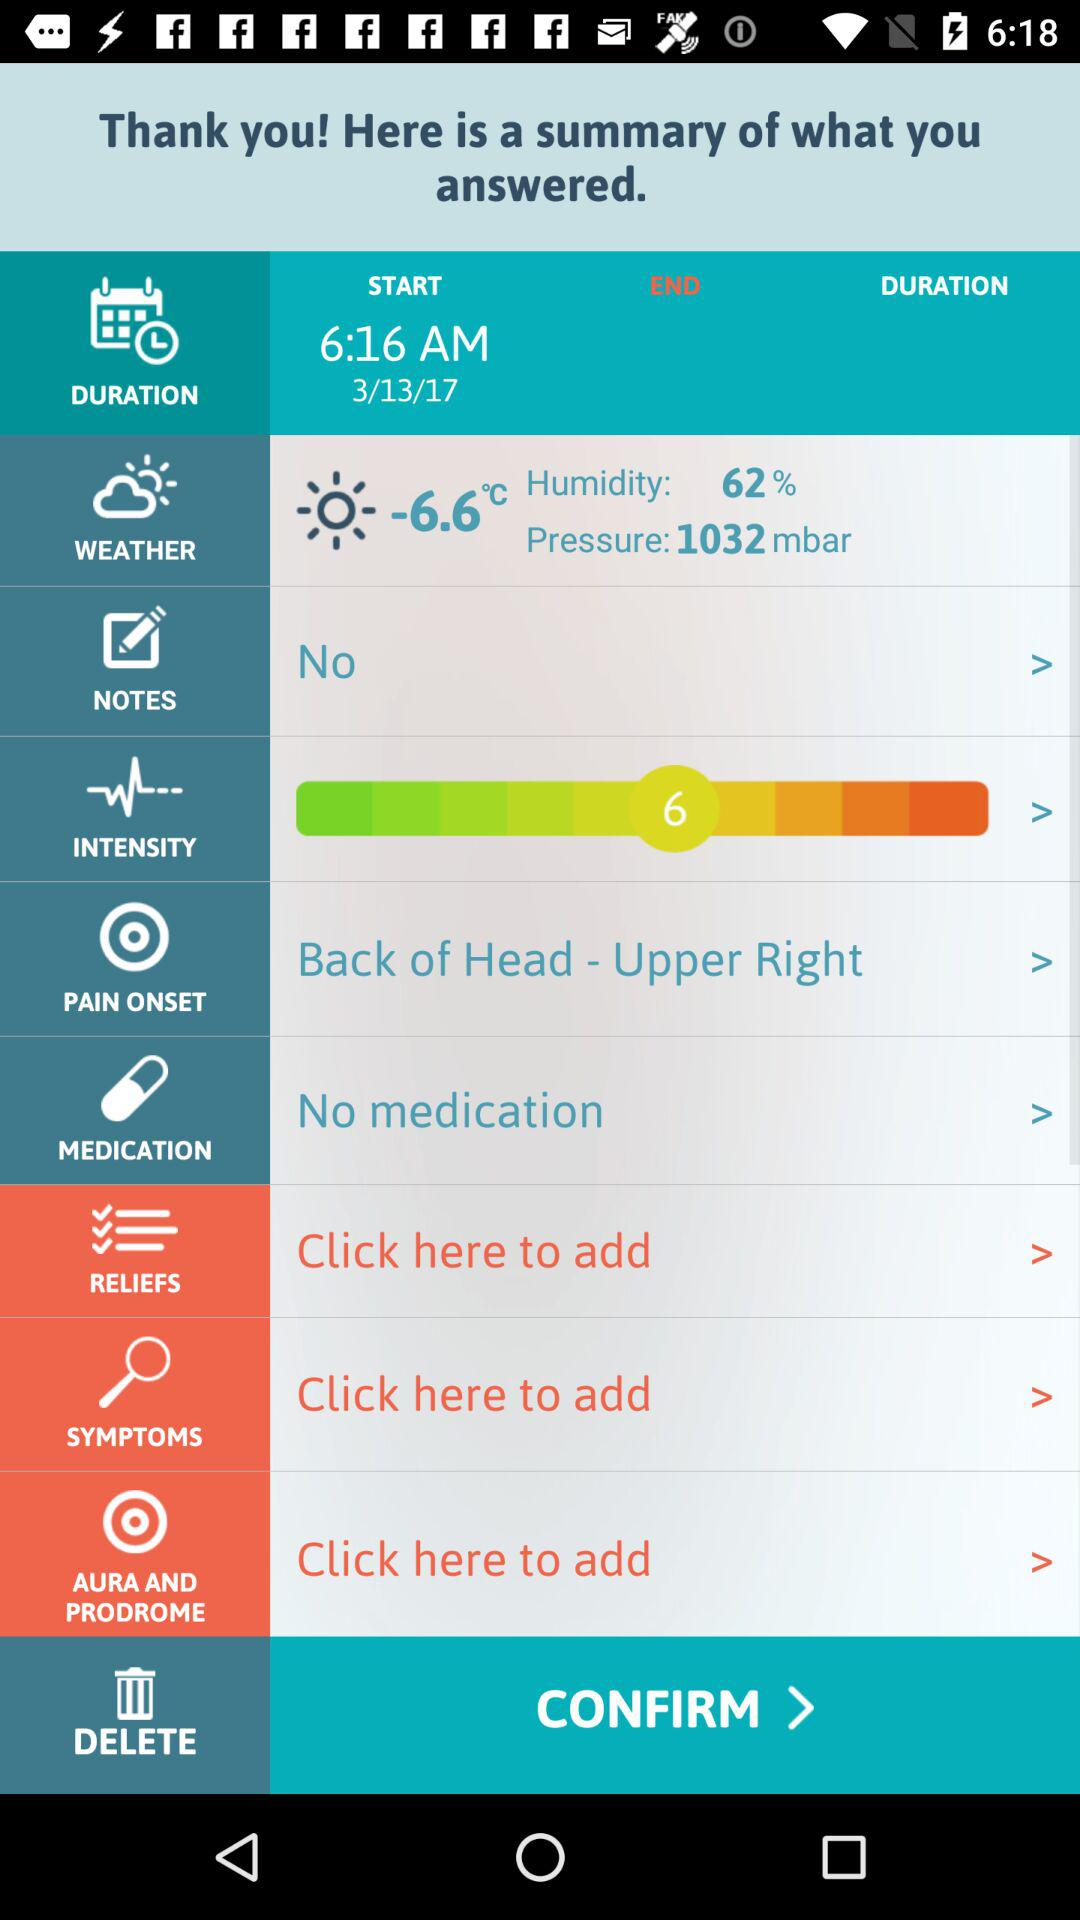How much is the temperature? The temperature is -6.6 °C. 